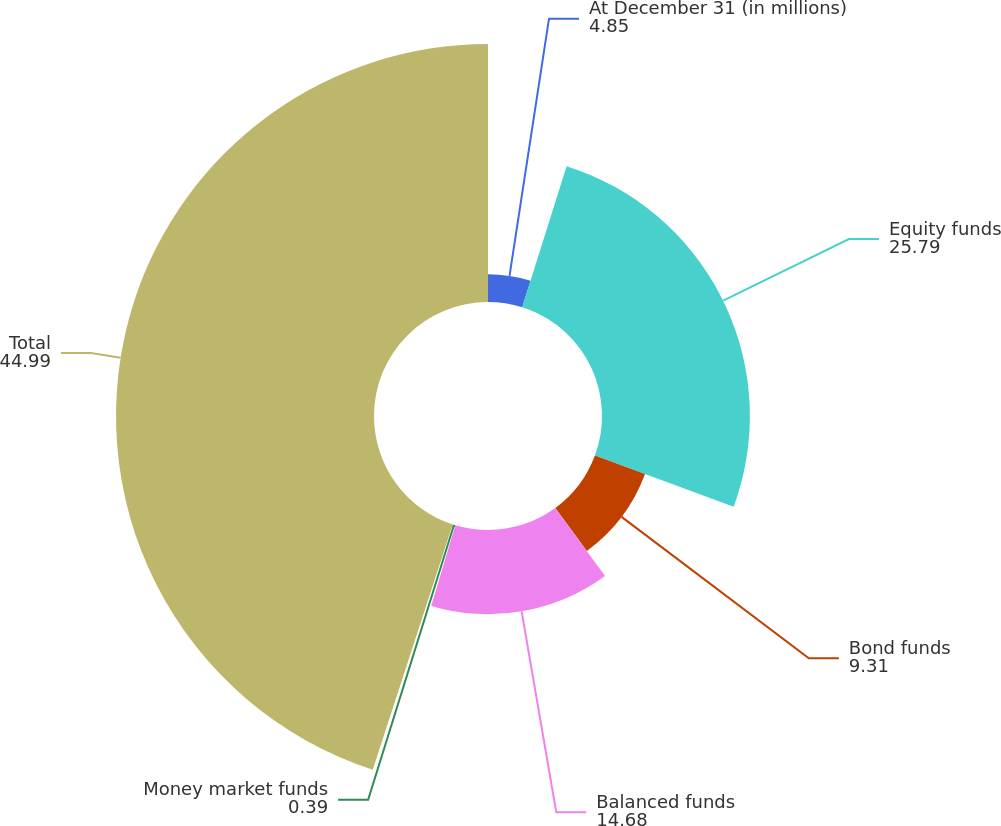Convert chart. <chart><loc_0><loc_0><loc_500><loc_500><pie_chart><fcel>At December 31 (in millions)<fcel>Equity funds<fcel>Bond funds<fcel>Balanced funds<fcel>Money market funds<fcel>Total<nl><fcel>4.85%<fcel>25.79%<fcel>9.31%<fcel>14.68%<fcel>0.39%<fcel>44.99%<nl></chart> 